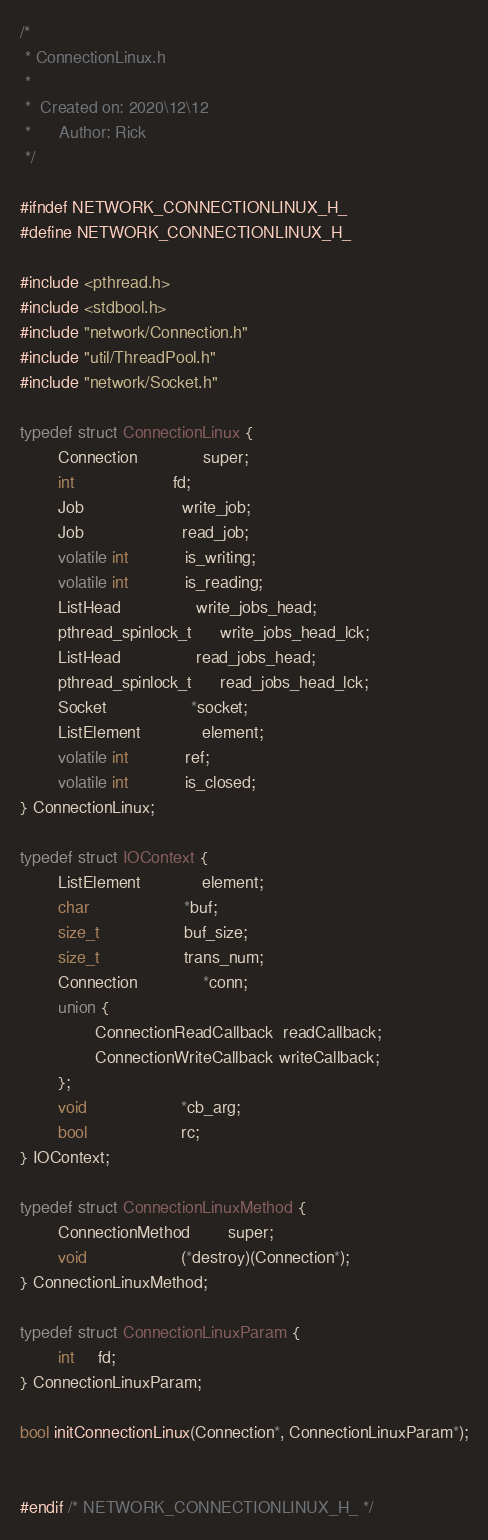<code> <loc_0><loc_0><loc_500><loc_500><_C_>/*
 * ConnectionLinux.h
 *
 *  Created on: 2020\12\12
 *      Author: Rick
 */

#ifndef NETWORK_CONNECTIONLINUX_H_
#define NETWORK_CONNECTIONLINUX_H_

#include <pthread.h>
#include <stdbool.h>
#include "network/Connection.h"
#include "util/ThreadPool.h"
#include "network/Socket.h"

typedef struct ConnectionLinux {
        Connection              super;
        int                     fd;
        Job                     write_job;
        Job                     read_job;
        volatile int            is_writing;
        volatile int            is_reading;
        ListHead                write_jobs_head;
        pthread_spinlock_t      write_jobs_head_lck;
        ListHead                read_jobs_head;
        pthread_spinlock_t      read_jobs_head_lck;
        Socket                  *socket;
        ListElement             element;
        volatile int            ref;
        volatile int            is_closed;
} ConnectionLinux;

typedef struct IOContext {
        ListElement             element;
        char                    *buf;
        size_t                  buf_size;
        size_t                  trans_num;
        Connection              *conn;
        union {
                ConnectionReadCallback  readCallback;
                ConnectionWriteCallback writeCallback;
        };
        void                    *cb_arg;
        bool                    rc;
} IOContext;

typedef struct ConnectionLinuxMethod {
        ConnectionMethod        super;
        void                    (*destroy)(Connection*);
} ConnectionLinuxMethod;

typedef struct ConnectionLinuxParam {
        int     fd;
} ConnectionLinuxParam;

bool initConnectionLinux(Connection*, ConnectionLinuxParam*);


#endif /* NETWORK_CONNECTIONLINUX_H_ */
</code> 